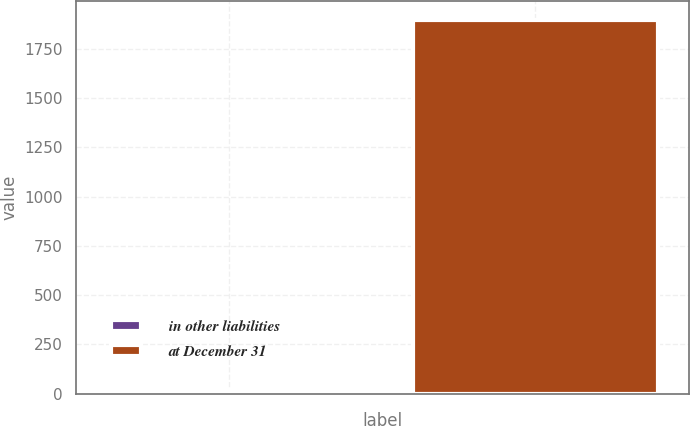Convert chart. <chart><loc_0><loc_0><loc_500><loc_500><bar_chart><fcel>in other liabilities<fcel>at December 31<nl><fcel>13<fcel>1897<nl></chart> 